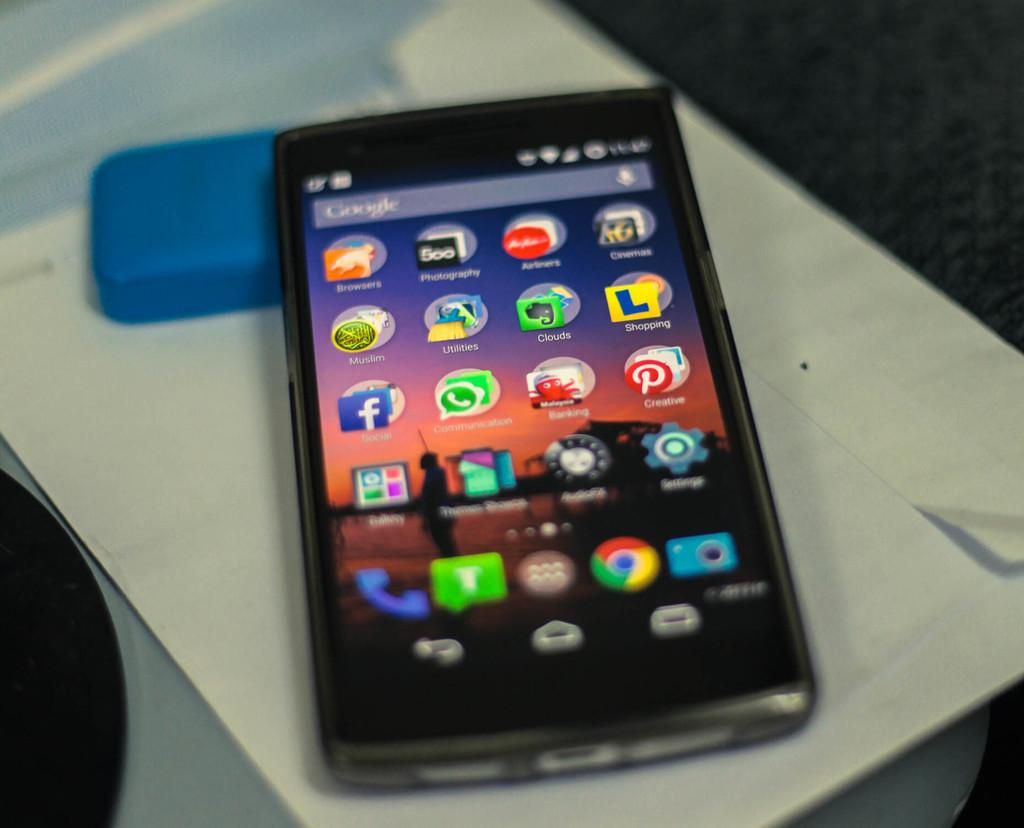<image>
Summarize the visual content of the image. A cell phone home page shows an f icon for facebook on the left. 